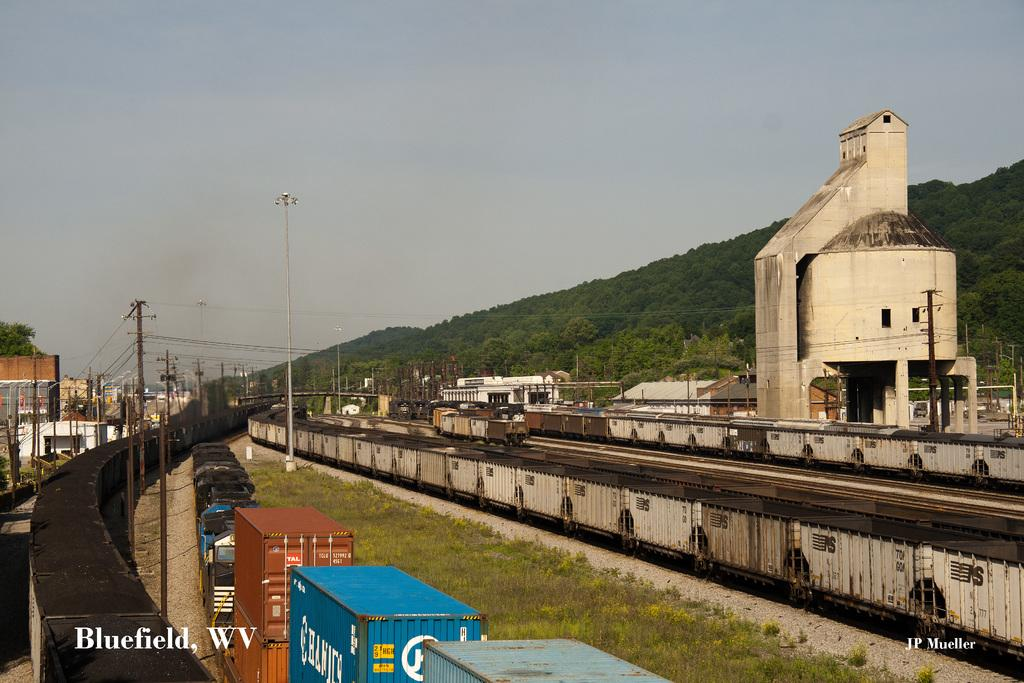What type of vehicles can be seen in the image? There are trains in the image. What else is present in the image besides trains? There are containers, poles with wires and lights, trees, buildings, and the sky is visible in the background. Can you describe the poles with wires and lights in the image? Yes, there are poles with wires and lights in the image. What type of structures are visible in the image? There are trees and buildings visible in the image. What scent can be detected from the tree in the image? There is no tree present in the image, so it is not possible to detect a scent from it. 